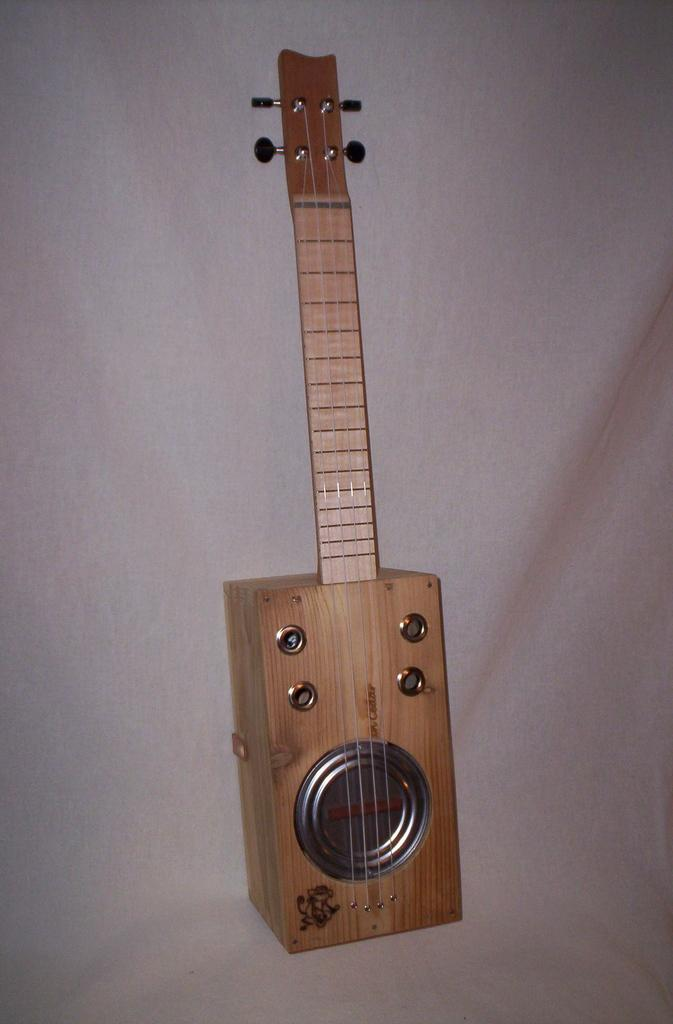What type of musical instrument is in the image? There is a wooden guitar in the image. Where is the wooden guitar located? The wooden guitar is lying on a bed. What type of pest can be seen crawling on the wooden guitar in the image? There is no pest visible on the wooden guitar in the image. What type of engine is powering the wooden guitar in the image? Wooden guitars do not have engines; they are played by hand or with a pick. 